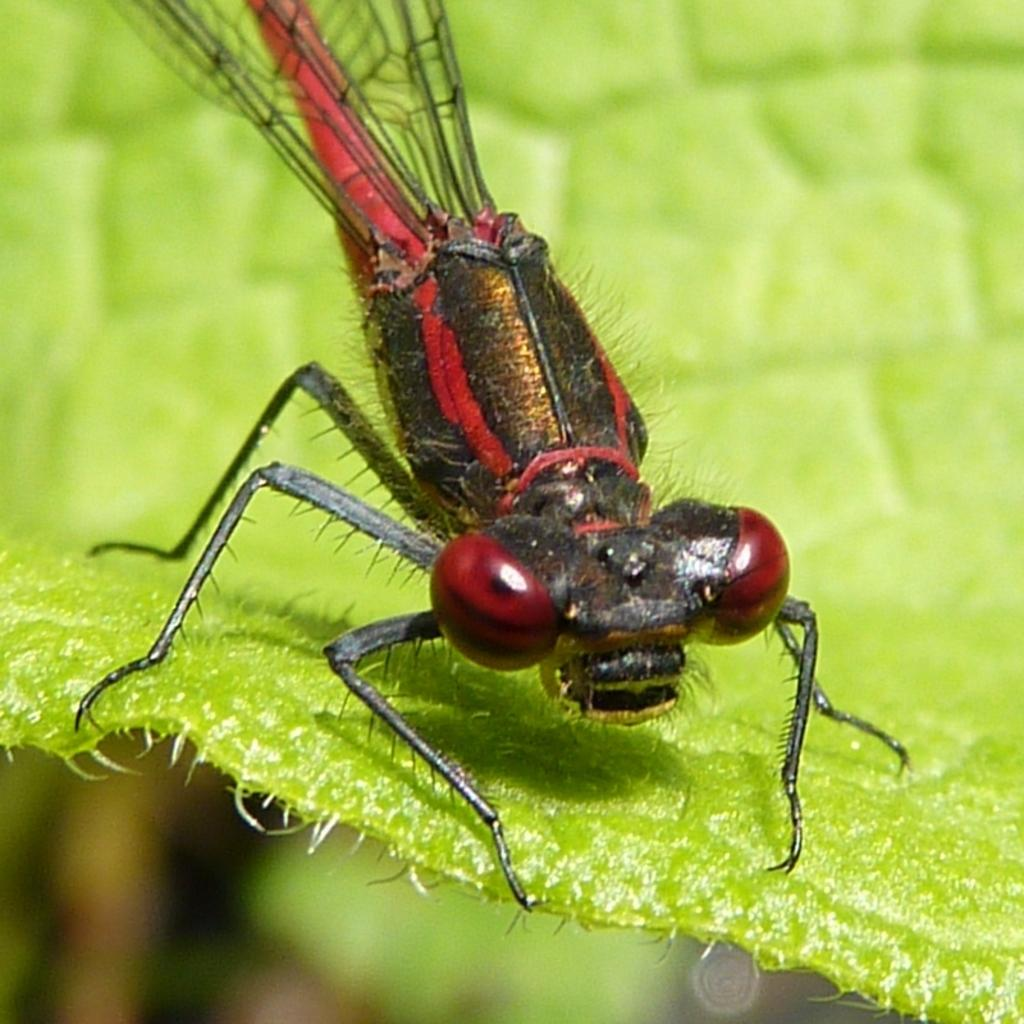What is the main subject of the image? The main subject of the image is a dragonfly. Where is the dragonfly located in the image? The dragonfly is on a green leaf. What colors can be seen on the dragonfly? The dragonfly is in black and red colors. What type of game is being played in the image? There is no game being played in the image; it features a dragonfly on a green leaf. What type of rail can be seen supporting the leaf in the image? There is no rail present in the image; it only shows a dragonfly on a green leaf. 